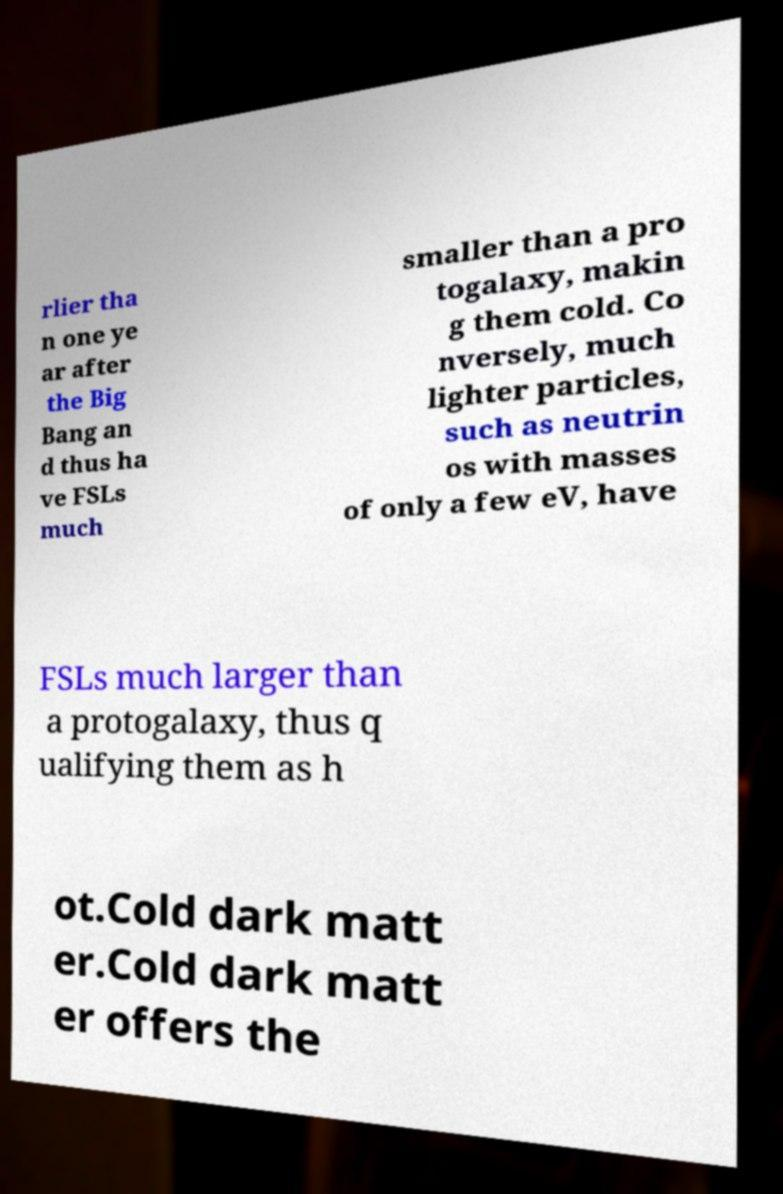Please read and relay the text visible in this image. What does it say? rlier tha n one ye ar after the Big Bang an d thus ha ve FSLs much smaller than a pro togalaxy, makin g them cold. Co nversely, much lighter particles, such as neutrin os with masses of only a few eV, have FSLs much larger than a protogalaxy, thus q ualifying them as h ot.Cold dark matt er.Cold dark matt er offers the 